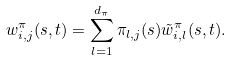Convert formula to latex. <formula><loc_0><loc_0><loc_500><loc_500>w _ { i , j } ^ { \pi } ( s , t ) = \sum _ { l = 1 } ^ { d _ { \pi } } \pi _ { l , j } ( s ) \tilde { w } ^ { \pi } _ { i , l } ( s , t ) .</formula> 